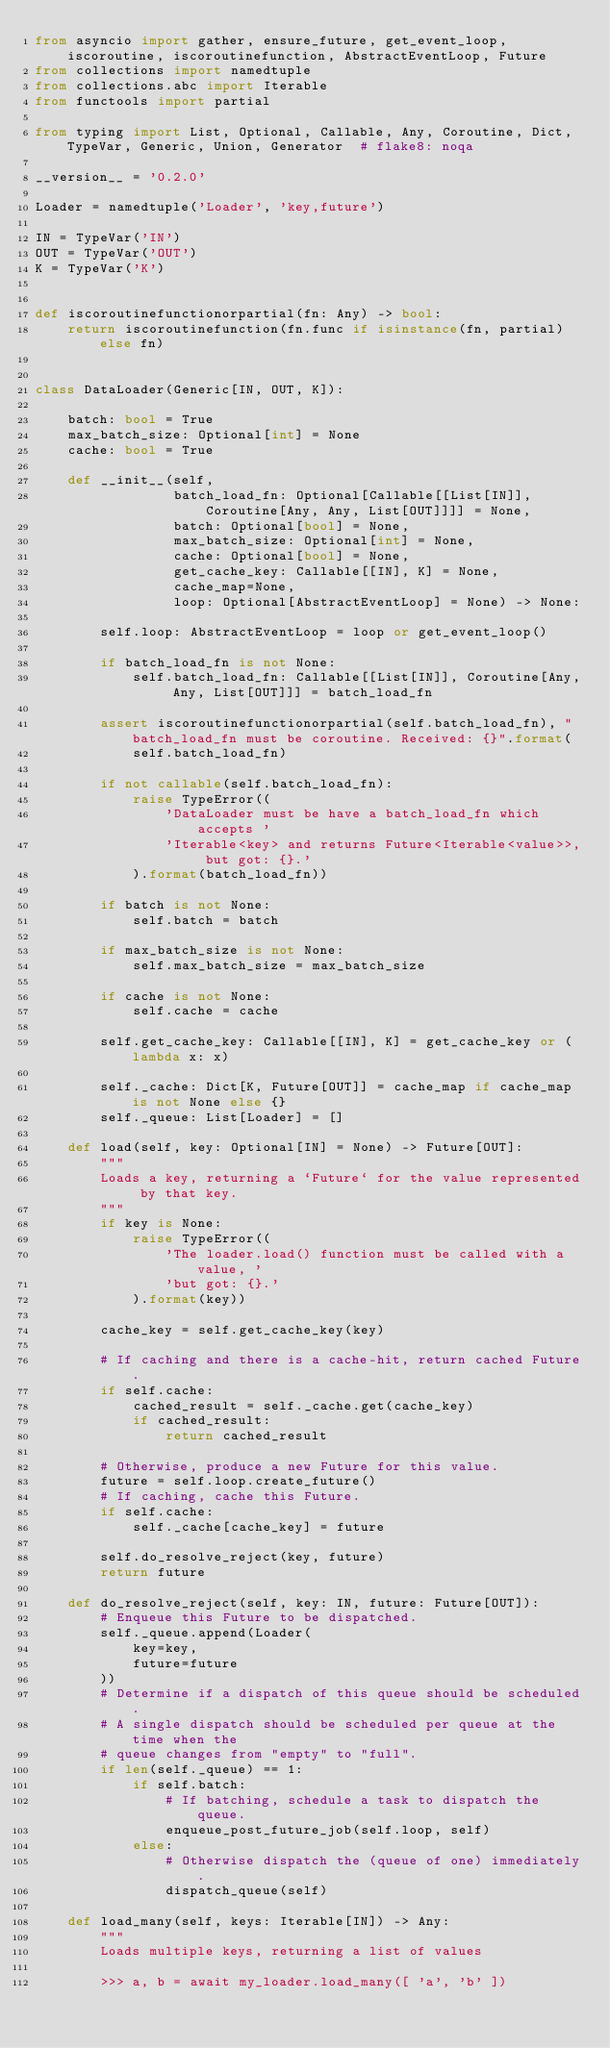<code> <loc_0><loc_0><loc_500><loc_500><_Python_>from asyncio import gather, ensure_future, get_event_loop, iscoroutine, iscoroutinefunction, AbstractEventLoop, Future
from collections import namedtuple
from collections.abc import Iterable
from functools import partial

from typing import List, Optional, Callable, Any, Coroutine, Dict, TypeVar, Generic, Union, Generator  # flake8: noqa

__version__ = '0.2.0'

Loader = namedtuple('Loader', 'key,future')

IN = TypeVar('IN')
OUT = TypeVar('OUT')
K = TypeVar('K')


def iscoroutinefunctionorpartial(fn: Any) -> bool:
    return iscoroutinefunction(fn.func if isinstance(fn, partial) else fn)


class DataLoader(Generic[IN, OUT, K]):

    batch: bool = True
    max_batch_size: Optional[int] = None
    cache: bool = True

    def __init__(self,
                 batch_load_fn: Optional[Callable[[List[IN]], Coroutine[Any, Any, List[OUT]]]] = None,
                 batch: Optional[bool] = None,
                 max_batch_size: Optional[int] = None,
                 cache: Optional[bool] = None,
                 get_cache_key: Callable[[IN], K] = None,
                 cache_map=None,
                 loop: Optional[AbstractEventLoop] = None) -> None:

        self.loop: AbstractEventLoop = loop or get_event_loop()

        if batch_load_fn is not None:
            self.batch_load_fn: Callable[[List[IN]], Coroutine[Any, Any, List[OUT]]] = batch_load_fn

        assert iscoroutinefunctionorpartial(self.batch_load_fn), "batch_load_fn must be coroutine. Received: {}".format(
            self.batch_load_fn)

        if not callable(self.batch_load_fn):
            raise TypeError((
                'DataLoader must be have a batch_load_fn which accepts '
                'Iterable<key> and returns Future<Iterable<value>>, but got: {}.'
            ).format(batch_load_fn))

        if batch is not None:
            self.batch = batch

        if max_batch_size is not None:
            self.max_batch_size = max_batch_size

        if cache is not None:
            self.cache = cache

        self.get_cache_key: Callable[[IN], K] = get_cache_key or (lambda x: x)

        self._cache: Dict[K, Future[OUT]] = cache_map if cache_map is not None else {}
        self._queue: List[Loader] = []

    def load(self, key: Optional[IN] = None) -> Future[OUT]:
        """
        Loads a key, returning a `Future` for the value represented by that key.
        """
        if key is None:
            raise TypeError((
                'The loader.load() function must be called with a value, '
                'but got: {}.'
            ).format(key))

        cache_key = self.get_cache_key(key)

        # If caching and there is a cache-hit, return cached Future.
        if self.cache:
            cached_result = self._cache.get(cache_key)
            if cached_result:
                return cached_result

        # Otherwise, produce a new Future for this value.
        future = self.loop.create_future()
        # If caching, cache this Future.
        if self.cache:
            self._cache[cache_key] = future

        self.do_resolve_reject(key, future)
        return future

    def do_resolve_reject(self, key: IN, future: Future[OUT]):
        # Enqueue this Future to be dispatched.
        self._queue.append(Loader(
            key=key,
            future=future
        ))
        # Determine if a dispatch of this queue should be scheduled.
        # A single dispatch should be scheduled per queue at the time when the
        # queue changes from "empty" to "full".
        if len(self._queue) == 1:
            if self.batch:
                # If batching, schedule a task to dispatch the queue.
                enqueue_post_future_job(self.loop, self)
            else:
                # Otherwise dispatch the (queue of one) immediately.
                dispatch_queue(self)

    def load_many(self, keys: Iterable[IN]) -> Any:
        """
        Loads multiple keys, returning a list of values

        >>> a, b = await my_loader.load_many([ 'a', 'b' ])
</code> 